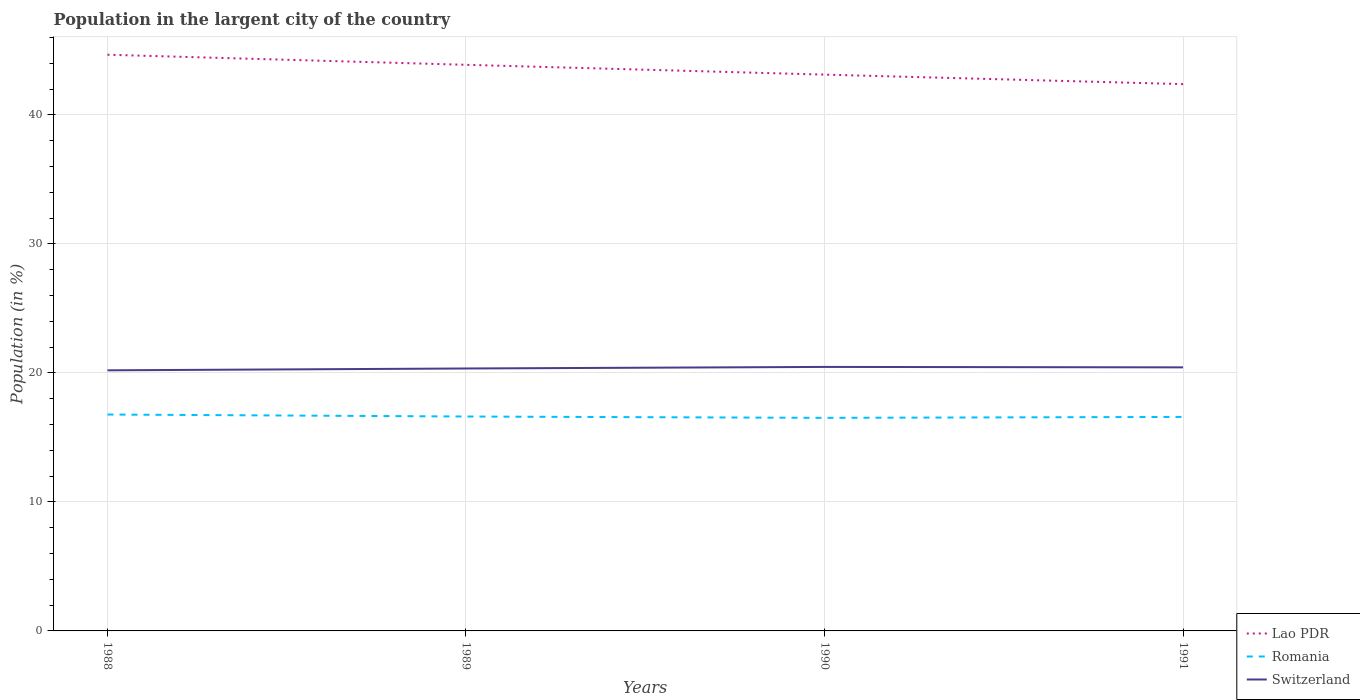How many different coloured lines are there?
Give a very brief answer. 3. Does the line corresponding to Romania intersect with the line corresponding to Switzerland?
Keep it short and to the point. No. Is the number of lines equal to the number of legend labels?
Provide a short and direct response. Yes. Across all years, what is the maximum percentage of population in the largent city in Romania?
Make the answer very short. 16.52. What is the total percentage of population in the largent city in Lao PDR in the graph?
Your response must be concise. 0.78. What is the difference between the highest and the second highest percentage of population in the largent city in Lao PDR?
Ensure brevity in your answer.  2.28. Is the percentage of population in the largent city in Switzerland strictly greater than the percentage of population in the largent city in Lao PDR over the years?
Provide a succinct answer. Yes. Are the values on the major ticks of Y-axis written in scientific E-notation?
Make the answer very short. No. Does the graph contain any zero values?
Your answer should be compact. No. How are the legend labels stacked?
Ensure brevity in your answer.  Vertical. What is the title of the graph?
Offer a terse response. Population in the largent city of the country. Does "Korea (Democratic)" appear as one of the legend labels in the graph?
Ensure brevity in your answer.  No. What is the label or title of the X-axis?
Provide a succinct answer. Years. What is the Population (in %) of Lao PDR in 1988?
Make the answer very short. 44.67. What is the Population (in %) of Romania in 1988?
Your response must be concise. 16.78. What is the Population (in %) of Switzerland in 1988?
Keep it short and to the point. 20.2. What is the Population (in %) of Lao PDR in 1989?
Offer a terse response. 43.89. What is the Population (in %) of Romania in 1989?
Give a very brief answer. 16.62. What is the Population (in %) in Switzerland in 1989?
Keep it short and to the point. 20.35. What is the Population (in %) of Lao PDR in 1990?
Make the answer very short. 43.13. What is the Population (in %) in Romania in 1990?
Ensure brevity in your answer.  16.52. What is the Population (in %) of Switzerland in 1990?
Give a very brief answer. 20.47. What is the Population (in %) of Lao PDR in 1991?
Provide a succinct answer. 42.39. What is the Population (in %) in Romania in 1991?
Offer a terse response. 16.59. What is the Population (in %) in Switzerland in 1991?
Give a very brief answer. 20.43. Across all years, what is the maximum Population (in %) in Lao PDR?
Offer a very short reply. 44.67. Across all years, what is the maximum Population (in %) of Romania?
Offer a terse response. 16.78. Across all years, what is the maximum Population (in %) of Switzerland?
Give a very brief answer. 20.47. Across all years, what is the minimum Population (in %) in Lao PDR?
Your answer should be very brief. 42.39. Across all years, what is the minimum Population (in %) of Romania?
Provide a short and direct response. 16.52. Across all years, what is the minimum Population (in %) in Switzerland?
Provide a short and direct response. 20.2. What is the total Population (in %) of Lao PDR in the graph?
Make the answer very short. 174.08. What is the total Population (in %) of Romania in the graph?
Your answer should be compact. 66.51. What is the total Population (in %) of Switzerland in the graph?
Make the answer very short. 81.45. What is the difference between the Population (in %) of Lao PDR in 1988 and that in 1989?
Your answer should be compact. 0.78. What is the difference between the Population (in %) in Romania in 1988 and that in 1989?
Offer a terse response. 0.15. What is the difference between the Population (in %) in Switzerland in 1988 and that in 1989?
Your answer should be compact. -0.14. What is the difference between the Population (in %) in Lao PDR in 1988 and that in 1990?
Give a very brief answer. 1.54. What is the difference between the Population (in %) of Romania in 1988 and that in 1990?
Your response must be concise. 0.26. What is the difference between the Population (in %) of Switzerland in 1988 and that in 1990?
Keep it short and to the point. -0.26. What is the difference between the Population (in %) of Lao PDR in 1988 and that in 1991?
Make the answer very short. 2.28. What is the difference between the Population (in %) in Romania in 1988 and that in 1991?
Ensure brevity in your answer.  0.19. What is the difference between the Population (in %) in Switzerland in 1988 and that in 1991?
Make the answer very short. -0.23. What is the difference between the Population (in %) in Lao PDR in 1989 and that in 1990?
Ensure brevity in your answer.  0.76. What is the difference between the Population (in %) in Romania in 1989 and that in 1990?
Ensure brevity in your answer.  0.1. What is the difference between the Population (in %) in Switzerland in 1989 and that in 1990?
Provide a short and direct response. -0.12. What is the difference between the Population (in %) of Lao PDR in 1989 and that in 1991?
Provide a short and direct response. 1.5. What is the difference between the Population (in %) of Romania in 1989 and that in 1991?
Provide a succinct answer. 0.03. What is the difference between the Population (in %) in Switzerland in 1989 and that in 1991?
Ensure brevity in your answer.  -0.09. What is the difference between the Population (in %) of Lao PDR in 1990 and that in 1991?
Ensure brevity in your answer.  0.74. What is the difference between the Population (in %) in Romania in 1990 and that in 1991?
Make the answer very short. -0.07. What is the difference between the Population (in %) of Switzerland in 1990 and that in 1991?
Provide a succinct answer. 0.03. What is the difference between the Population (in %) of Lao PDR in 1988 and the Population (in %) of Romania in 1989?
Keep it short and to the point. 28.05. What is the difference between the Population (in %) in Lao PDR in 1988 and the Population (in %) in Switzerland in 1989?
Offer a very short reply. 24.32. What is the difference between the Population (in %) of Romania in 1988 and the Population (in %) of Switzerland in 1989?
Make the answer very short. -3.57. What is the difference between the Population (in %) of Lao PDR in 1988 and the Population (in %) of Romania in 1990?
Your answer should be compact. 28.15. What is the difference between the Population (in %) of Lao PDR in 1988 and the Population (in %) of Switzerland in 1990?
Provide a short and direct response. 24.2. What is the difference between the Population (in %) of Romania in 1988 and the Population (in %) of Switzerland in 1990?
Provide a short and direct response. -3.69. What is the difference between the Population (in %) in Lao PDR in 1988 and the Population (in %) in Romania in 1991?
Keep it short and to the point. 28.08. What is the difference between the Population (in %) in Lao PDR in 1988 and the Population (in %) in Switzerland in 1991?
Provide a succinct answer. 24.24. What is the difference between the Population (in %) in Romania in 1988 and the Population (in %) in Switzerland in 1991?
Provide a succinct answer. -3.66. What is the difference between the Population (in %) of Lao PDR in 1989 and the Population (in %) of Romania in 1990?
Make the answer very short. 27.37. What is the difference between the Population (in %) in Lao PDR in 1989 and the Population (in %) in Switzerland in 1990?
Your answer should be compact. 23.42. What is the difference between the Population (in %) in Romania in 1989 and the Population (in %) in Switzerland in 1990?
Provide a short and direct response. -3.84. What is the difference between the Population (in %) of Lao PDR in 1989 and the Population (in %) of Romania in 1991?
Give a very brief answer. 27.3. What is the difference between the Population (in %) of Lao PDR in 1989 and the Population (in %) of Switzerland in 1991?
Provide a succinct answer. 23.45. What is the difference between the Population (in %) in Romania in 1989 and the Population (in %) in Switzerland in 1991?
Provide a short and direct response. -3.81. What is the difference between the Population (in %) of Lao PDR in 1990 and the Population (in %) of Romania in 1991?
Offer a very short reply. 26.54. What is the difference between the Population (in %) in Lao PDR in 1990 and the Population (in %) in Switzerland in 1991?
Give a very brief answer. 22.69. What is the difference between the Population (in %) of Romania in 1990 and the Population (in %) of Switzerland in 1991?
Your answer should be very brief. -3.91. What is the average Population (in %) in Lao PDR per year?
Give a very brief answer. 43.52. What is the average Population (in %) in Romania per year?
Your answer should be very brief. 16.63. What is the average Population (in %) of Switzerland per year?
Give a very brief answer. 20.36. In the year 1988, what is the difference between the Population (in %) in Lao PDR and Population (in %) in Romania?
Give a very brief answer. 27.89. In the year 1988, what is the difference between the Population (in %) of Lao PDR and Population (in %) of Switzerland?
Offer a very short reply. 24.47. In the year 1988, what is the difference between the Population (in %) of Romania and Population (in %) of Switzerland?
Give a very brief answer. -3.43. In the year 1989, what is the difference between the Population (in %) of Lao PDR and Population (in %) of Romania?
Keep it short and to the point. 27.27. In the year 1989, what is the difference between the Population (in %) of Lao PDR and Population (in %) of Switzerland?
Your response must be concise. 23.54. In the year 1989, what is the difference between the Population (in %) in Romania and Population (in %) in Switzerland?
Your answer should be compact. -3.72. In the year 1990, what is the difference between the Population (in %) in Lao PDR and Population (in %) in Romania?
Keep it short and to the point. 26.61. In the year 1990, what is the difference between the Population (in %) in Lao PDR and Population (in %) in Switzerland?
Make the answer very short. 22.66. In the year 1990, what is the difference between the Population (in %) in Romania and Population (in %) in Switzerland?
Provide a succinct answer. -3.95. In the year 1991, what is the difference between the Population (in %) in Lao PDR and Population (in %) in Romania?
Your response must be concise. 25.8. In the year 1991, what is the difference between the Population (in %) of Lao PDR and Population (in %) of Switzerland?
Keep it short and to the point. 21.96. In the year 1991, what is the difference between the Population (in %) of Romania and Population (in %) of Switzerland?
Offer a terse response. -3.84. What is the ratio of the Population (in %) in Lao PDR in 1988 to that in 1989?
Provide a succinct answer. 1.02. What is the ratio of the Population (in %) in Romania in 1988 to that in 1989?
Offer a terse response. 1.01. What is the ratio of the Population (in %) of Lao PDR in 1988 to that in 1990?
Your answer should be compact. 1.04. What is the ratio of the Population (in %) of Romania in 1988 to that in 1990?
Provide a succinct answer. 1.02. What is the ratio of the Population (in %) of Switzerland in 1988 to that in 1990?
Ensure brevity in your answer.  0.99. What is the ratio of the Population (in %) of Lao PDR in 1988 to that in 1991?
Keep it short and to the point. 1.05. What is the ratio of the Population (in %) of Romania in 1988 to that in 1991?
Offer a terse response. 1.01. What is the ratio of the Population (in %) in Switzerland in 1988 to that in 1991?
Ensure brevity in your answer.  0.99. What is the ratio of the Population (in %) in Lao PDR in 1989 to that in 1990?
Offer a terse response. 1.02. What is the ratio of the Population (in %) in Lao PDR in 1989 to that in 1991?
Offer a terse response. 1.04. What is the ratio of the Population (in %) in Romania in 1989 to that in 1991?
Provide a succinct answer. 1. What is the ratio of the Population (in %) of Switzerland in 1989 to that in 1991?
Offer a terse response. 1. What is the ratio of the Population (in %) of Lao PDR in 1990 to that in 1991?
Your answer should be compact. 1.02. What is the difference between the highest and the second highest Population (in %) of Lao PDR?
Your response must be concise. 0.78. What is the difference between the highest and the second highest Population (in %) of Romania?
Keep it short and to the point. 0.15. What is the difference between the highest and the second highest Population (in %) of Switzerland?
Give a very brief answer. 0.03. What is the difference between the highest and the lowest Population (in %) of Lao PDR?
Your response must be concise. 2.28. What is the difference between the highest and the lowest Population (in %) of Romania?
Your response must be concise. 0.26. What is the difference between the highest and the lowest Population (in %) of Switzerland?
Keep it short and to the point. 0.26. 